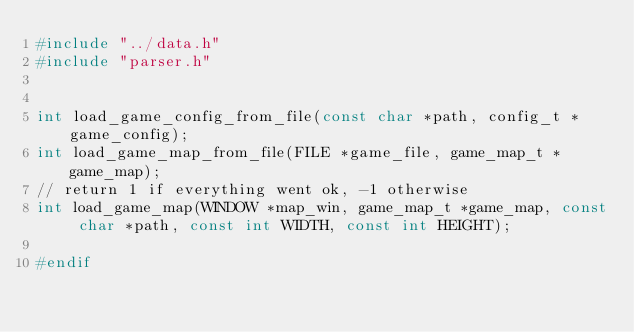<code> <loc_0><loc_0><loc_500><loc_500><_C_>#include "../data.h"
#include "parser.h"


int load_game_config_from_file(const char *path, config_t *game_config);
int load_game_map_from_file(FILE *game_file, game_map_t *game_map);
// return 1 if everything went ok, -1 otherwise
int load_game_map(WINDOW *map_win, game_map_t *game_map, const char *path, const int WIDTH, const int HEIGHT);

#endif 
</code> 